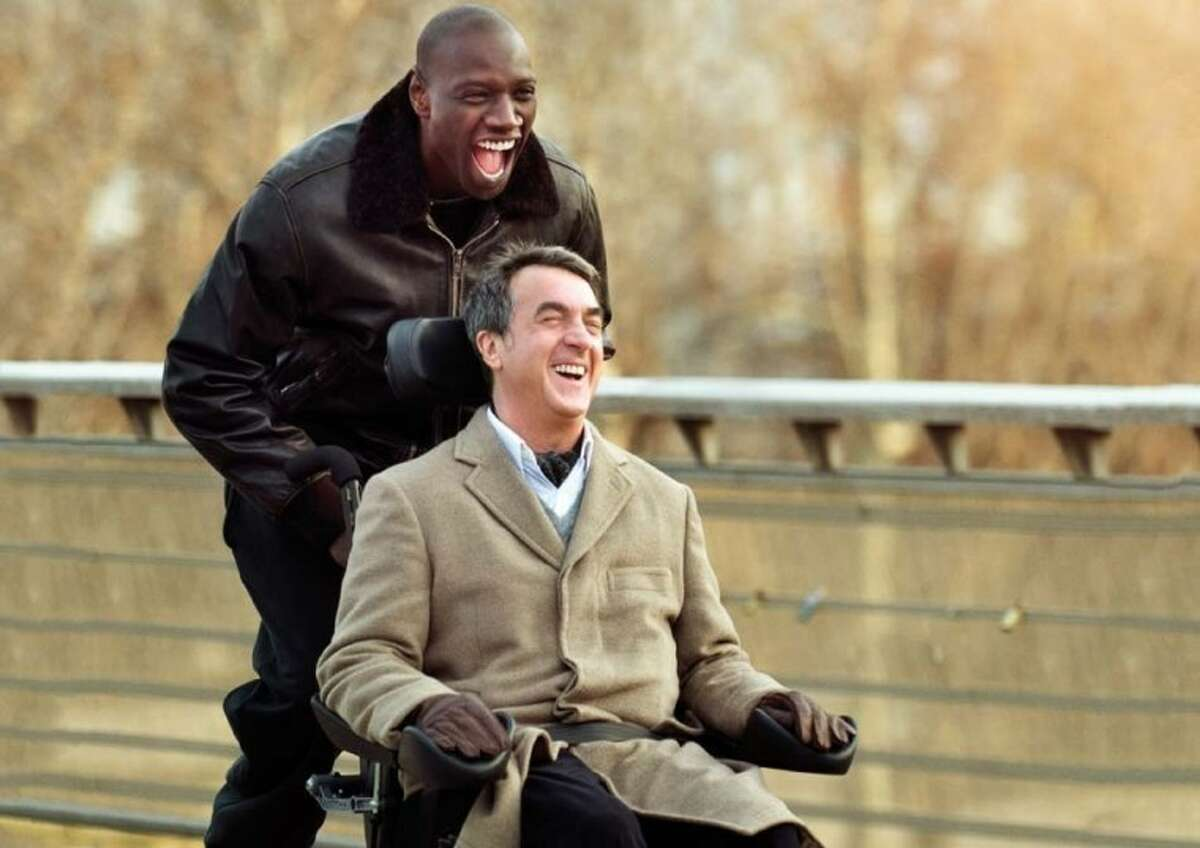What emotions do you think are being conveyed in this scene? The scene is a vivid portrayal of joy and companionship. Both individuals appear to be sharing a hearty laugh, which is a universal symbol of happiness and a bond that speaks to a warm, friendly interaction. Why do these emotions seem authentic to you? Authenticity in emotions can often be discerned through body language and facial expressions. Here, both individuals have wide smiles that reach their eyes, a natural physical response to genuine mirth. The open body language of the standing person, who's leaning slightly forward with his mouth open in laughter, suggests a spontaneous reaction to humor or joy, while the seated person's tilted head and broad grin suggest he's fully engaged in this shared experience, enhancing the perception of authenticity. 